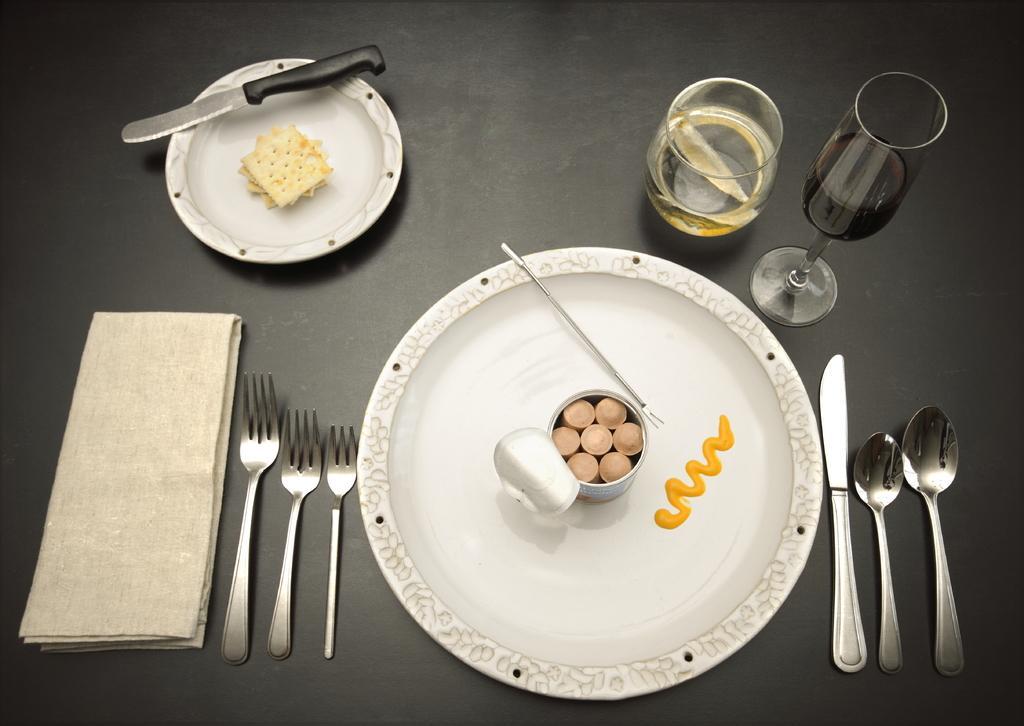In one or two sentences, can you explain what this image depicts? In the image there are two plates and there are some food items on those plates, around the first plate there are forks, knife, spoons, glasses and a napkin. 